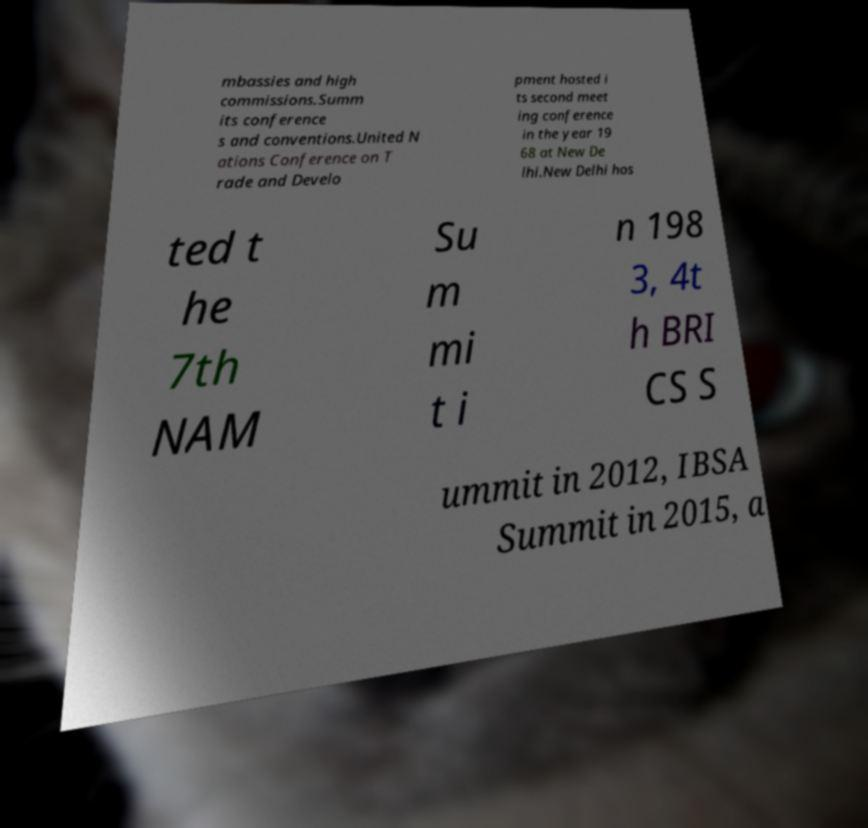Could you assist in decoding the text presented in this image and type it out clearly? mbassies and high commissions.Summ its conference s and conventions.United N ations Conference on T rade and Develo pment hosted i ts second meet ing conference in the year 19 68 at New De lhi.New Delhi hos ted t he 7th NAM Su m mi t i n 198 3, 4t h BRI CS S ummit in 2012, IBSA Summit in 2015, a 